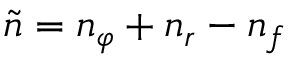<formula> <loc_0><loc_0><loc_500><loc_500>\tilde { n } = n _ { \varphi } + n _ { r } - n _ { f }</formula> 